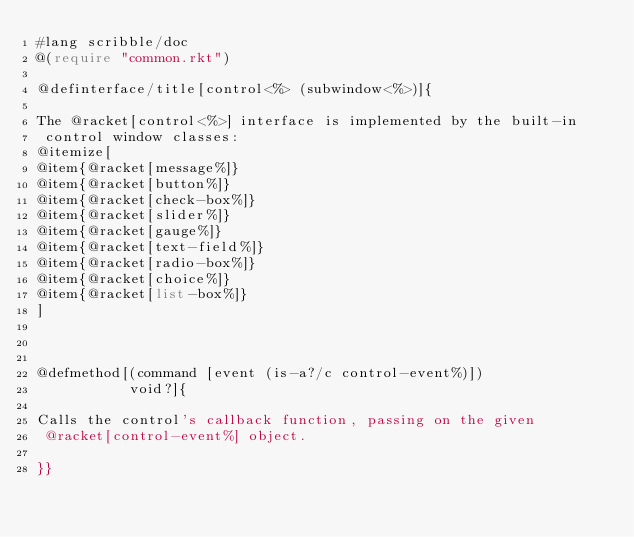Convert code to text. <code><loc_0><loc_0><loc_500><loc_500><_Racket_>#lang scribble/doc
@(require "common.rkt")

@definterface/title[control<%> (subwindow<%>)]{

The @racket[control<%>] interface is implemented by the built-in
 control window classes:
@itemize[
@item{@racket[message%]}
@item{@racket[button%]}
@item{@racket[check-box%]}
@item{@racket[slider%]}
@item{@racket[gauge%]}
@item{@racket[text-field%]}
@item{@racket[radio-box%]}
@item{@racket[choice%]}
@item{@racket[list-box%]}
]



@defmethod[(command [event (is-a?/c control-event%)])
           void?]{

Calls the control's callback function, passing on the given
 @racket[control-event%] object.

}}

</code> 